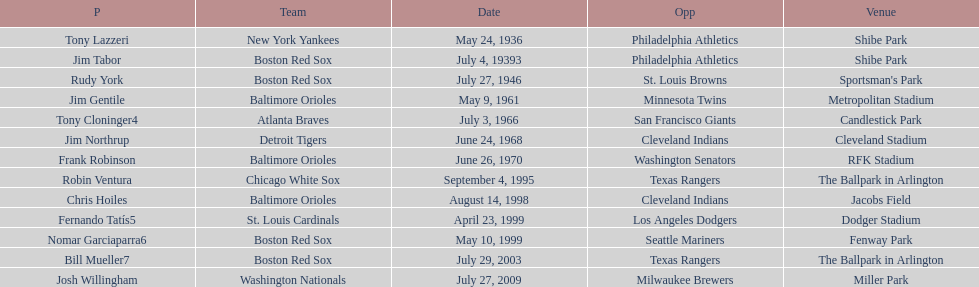On what date did the detroit tigers play the cleveland indians? June 24, 1968. 